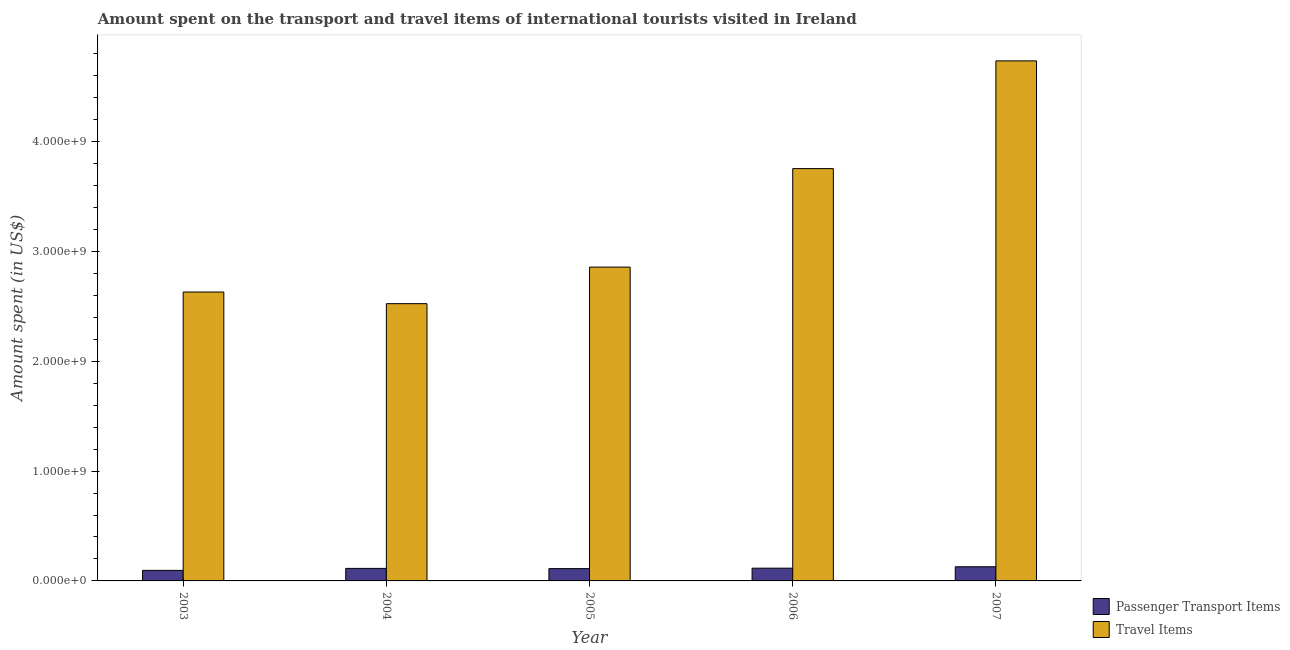How many different coloured bars are there?
Your response must be concise. 2. Are the number of bars per tick equal to the number of legend labels?
Your response must be concise. Yes. Are the number of bars on each tick of the X-axis equal?
Make the answer very short. Yes. How many bars are there on the 1st tick from the left?
Offer a very short reply. 2. How many bars are there on the 2nd tick from the right?
Offer a very short reply. 2. What is the label of the 2nd group of bars from the left?
Make the answer very short. 2004. What is the amount spent on passenger transport items in 2004?
Offer a terse response. 1.14e+08. Across all years, what is the maximum amount spent in travel items?
Give a very brief answer. 4.74e+09. Across all years, what is the minimum amount spent in travel items?
Offer a very short reply. 2.52e+09. In which year was the amount spent on passenger transport items maximum?
Make the answer very short. 2007. In which year was the amount spent in travel items minimum?
Keep it short and to the point. 2004. What is the total amount spent on passenger transport items in the graph?
Provide a short and direct response. 5.67e+08. What is the difference between the amount spent on passenger transport items in 2005 and that in 2006?
Offer a terse response. -4.00e+06. What is the difference between the amount spent in travel items in 2005 and the amount spent on passenger transport items in 2007?
Ensure brevity in your answer.  -1.88e+09. What is the average amount spent in travel items per year?
Keep it short and to the point. 3.30e+09. In the year 2005, what is the difference between the amount spent on passenger transport items and amount spent in travel items?
Offer a terse response. 0. In how many years, is the amount spent in travel items greater than 3400000000 US$?
Provide a short and direct response. 2. What is the ratio of the amount spent in travel items in 2003 to that in 2007?
Make the answer very short. 0.56. Is the difference between the amount spent on passenger transport items in 2004 and 2005 greater than the difference between the amount spent in travel items in 2004 and 2005?
Offer a terse response. No. What is the difference between the highest and the second highest amount spent on passenger transport items?
Your answer should be very brief. 1.30e+07. What is the difference between the highest and the lowest amount spent in travel items?
Provide a succinct answer. 2.21e+09. In how many years, is the amount spent on passenger transport items greater than the average amount spent on passenger transport items taken over all years?
Your answer should be very brief. 3. Is the sum of the amount spent in travel items in 2004 and 2007 greater than the maximum amount spent on passenger transport items across all years?
Offer a terse response. Yes. What does the 1st bar from the left in 2007 represents?
Provide a short and direct response. Passenger Transport Items. What does the 2nd bar from the right in 2004 represents?
Give a very brief answer. Passenger Transport Items. Are the values on the major ticks of Y-axis written in scientific E-notation?
Provide a succinct answer. Yes. Does the graph contain any zero values?
Your answer should be very brief. No. How many legend labels are there?
Your answer should be compact. 2. How are the legend labels stacked?
Offer a very short reply. Vertical. What is the title of the graph?
Make the answer very short. Amount spent on the transport and travel items of international tourists visited in Ireland. What is the label or title of the Y-axis?
Provide a succinct answer. Amount spent (in US$). What is the Amount spent (in US$) of Passenger Transport Items in 2003?
Your answer should be compact. 9.60e+07. What is the Amount spent (in US$) of Travel Items in 2003?
Make the answer very short. 2.63e+09. What is the Amount spent (in US$) in Passenger Transport Items in 2004?
Make the answer very short. 1.14e+08. What is the Amount spent (in US$) in Travel Items in 2004?
Ensure brevity in your answer.  2.52e+09. What is the Amount spent (in US$) of Passenger Transport Items in 2005?
Offer a terse response. 1.12e+08. What is the Amount spent (in US$) of Travel Items in 2005?
Keep it short and to the point. 2.86e+09. What is the Amount spent (in US$) of Passenger Transport Items in 2006?
Make the answer very short. 1.16e+08. What is the Amount spent (in US$) in Travel Items in 2006?
Keep it short and to the point. 3.76e+09. What is the Amount spent (in US$) of Passenger Transport Items in 2007?
Ensure brevity in your answer.  1.29e+08. What is the Amount spent (in US$) in Travel Items in 2007?
Make the answer very short. 4.74e+09. Across all years, what is the maximum Amount spent (in US$) of Passenger Transport Items?
Make the answer very short. 1.29e+08. Across all years, what is the maximum Amount spent (in US$) of Travel Items?
Provide a succinct answer. 4.74e+09. Across all years, what is the minimum Amount spent (in US$) of Passenger Transport Items?
Keep it short and to the point. 9.60e+07. Across all years, what is the minimum Amount spent (in US$) in Travel Items?
Make the answer very short. 2.52e+09. What is the total Amount spent (in US$) of Passenger Transport Items in the graph?
Give a very brief answer. 5.67e+08. What is the total Amount spent (in US$) in Travel Items in the graph?
Provide a short and direct response. 1.65e+1. What is the difference between the Amount spent (in US$) of Passenger Transport Items in 2003 and that in 2004?
Provide a short and direct response. -1.80e+07. What is the difference between the Amount spent (in US$) of Travel Items in 2003 and that in 2004?
Offer a very short reply. 1.06e+08. What is the difference between the Amount spent (in US$) of Passenger Transport Items in 2003 and that in 2005?
Provide a short and direct response. -1.60e+07. What is the difference between the Amount spent (in US$) in Travel Items in 2003 and that in 2005?
Offer a very short reply. -2.27e+08. What is the difference between the Amount spent (in US$) of Passenger Transport Items in 2003 and that in 2006?
Your answer should be very brief. -2.00e+07. What is the difference between the Amount spent (in US$) of Travel Items in 2003 and that in 2006?
Offer a very short reply. -1.12e+09. What is the difference between the Amount spent (in US$) of Passenger Transport Items in 2003 and that in 2007?
Keep it short and to the point. -3.30e+07. What is the difference between the Amount spent (in US$) of Travel Items in 2003 and that in 2007?
Make the answer very short. -2.10e+09. What is the difference between the Amount spent (in US$) in Passenger Transport Items in 2004 and that in 2005?
Your answer should be very brief. 2.00e+06. What is the difference between the Amount spent (in US$) in Travel Items in 2004 and that in 2005?
Make the answer very short. -3.33e+08. What is the difference between the Amount spent (in US$) in Travel Items in 2004 and that in 2006?
Ensure brevity in your answer.  -1.23e+09. What is the difference between the Amount spent (in US$) of Passenger Transport Items in 2004 and that in 2007?
Offer a very short reply. -1.50e+07. What is the difference between the Amount spent (in US$) in Travel Items in 2004 and that in 2007?
Your answer should be compact. -2.21e+09. What is the difference between the Amount spent (in US$) in Travel Items in 2005 and that in 2006?
Your response must be concise. -8.97e+08. What is the difference between the Amount spent (in US$) of Passenger Transport Items in 2005 and that in 2007?
Make the answer very short. -1.70e+07. What is the difference between the Amount spent (in US$) of Travel Items in 2005 and that in 2007?
Offer a very short reply. -1.88e+09. What is the difference between the Amount spent (in US$) in Passenger Transport Items in 2006 and that in 2007?
Provide a short and direct response. -1.30e+07. What is the difference between the Amount spent (in US$) of Travel Items in 2006 and that in 2007?
Keep it short and to the point. -9.81e+08. What is the difference between the Amount spent (in US$) of Passenger Transport Items in 2003 and the Amount spent (in US$) of Travel Items in 2004?
Offer a terse response. -2.43e+09. What is the difference between the Amount spent (in US$) in Passenger Transport Items in 2003 and the Amount spent (in US$) in Travel Items in 2005?
Offer a very short reply. -2.76e+09. What is the difference between the Amount spent (in US$) of Passenger Transport Items in 2003 and the Amount spent (in US$) of Travel Items in 2006?
Offer a terse response. -3.66e+09. What is the difference between the Amount spent (in US$) in Passenger Transport Items in 2003 and the Amount spent (in US$) in Travel Items in 2007?
Keep it short and to the point. -4.64e+09. What is the difference between the Amount spent (in US$) in Passenger Transport Items in 2004 and the Amount spent (in US$) in Travel Items in 2005?
Give a very brief answer. -2.74e+09. What is the difference between the Amount spent (in US$) of Passenger Transport Items in 2004 and the Amount spent (in US$) of Travel Items in 2006?
Your answer should be compact. -3.64e+09. What is the difference between the Amount spent (in US$) in Passenger Transport Items in 2004 and the Amount spent (in US$) in Travel Items in 2007?
Your answer should be very brief. -4.62e+09. What is the difference between the Amount spent (in US$) in Passenger Transport Items in 2005 and the Amount spent (in US$) in Travel Items in 2006?
Give a very brief answer. -3.64e+09. What is the difference between the Amount spent (in US$) of Passenger Transport Items in 2005 and the Amount spent (in US$) of Travel Items in 2007?
Your answer should be very brief. -4.62e+09. What is the difference between the Amount spent (in US$) of Passenger Transport Items in 2006 and the Amount spent (in US$) of Travel Items in 2007?
Your answer should be compact. -4.62e+09. What is the average Amount spent (in US$) in Passenger Transport Items per year?
Give a very brief answer. 1.13e+08. What is the average Amount spent (in US$) of Travel Items per year?
Your answer should be very brief. 3.30e+09. In the year 2003, what is the difference between the Amount spent (in US$) in Passenger Transport Items and Amount spent (in US$) in Travel Items?
Offer a terse response. -2.54e+09. In the year 2004, what is the difference between the Amount spent (in US$) of Passenger Transport Items and Amount spent (in US$) of Travel Items?
Your answer should be very brief. -2.41e+09. In the year 2005, what is the difference between the Amount spent (in US$) of Passenger Transport Items and Amount spent (in US$) of Travel Items?
Offer a terse response. -2.75e+09. In the year 2006, what is the difference between the Amount spent (in US$) of Passenger Transport Items and Amount spent (in US$) of Travel Items?
Offer a very short reply. -3.64e+09. In the year 2007, what is the difference between the Amount spent (in US$) of Passenger Transport Items and Amount spent (in US$) of Travel Items?
Keep it short and to the point. -4.61e+09. What is the ratio of the Amount spent (in US$) of Passenger Transport Items in 2003 to that in 2004?
Make the answer very short. 0.84. What is the ratio of the Amount spent (in US$) in Travel Items in 2003 to that in 2004?
Provide a succinct answer. 1.04. What is the ratio of the Amount spent (in US$) of Travel Items in 2003 to that in 2005?
Ensure brevity in your answer.  0.92. What is the ratio of the Amount spent (in US$) in Passenger Transport Items in 2003 to that in 2006?
Provide a short and direct response. 0.83. What is the ratio of the Amount spent (in US$) of Travel Items in 2003 to that in 2006?
Offer a very short reply. 0.7. What is the ratio of the Amount spent (in US$) in Passenger Transport Items in 2003 to that in 2007?
Your answer should be very brief. 0.74. What is the ratio of the Amount spent (in US$) in Travel Items in 2003 to that in 2007?
Keep it short and to the point. 0.56. What is the ratio of the Amount spent (in US$) of Passenger Transport Items in 2004 to that in 2005?
Ensure brevity in your answer.  1.02. What is the ratio of the Amount spent (in US$) in Travel Items in 2004 to that in 2005?
Offer a terse response. 0.88. What is the ratio of the Amount spent (in US$) of Passenger Transport Items in 2004 to that in 2006?
Give a very brief answer. 0.98. What is the ratio of the Amount spent (in US$) in Travel Items in 2004 to that in 2006?
Your answer should be very brief. 0.67. What is the ratio of the Amount spent (in US$) of Passenger Transport Items in 2004 to that in 2007?
Your answer should be very brief. 0.88. What is the ratio of the Amount spent (in US$) in Travel Items in 2004 to that in 2007?
Keep it short and to the point. 0.53. What is the ratio of the Amount spent (in US$) of Passenger Transport Items in 2005 to that in 2006?
Keep it short and to the point. 0.97. What is the ratio of the Amount spent (in US$) in Travel Items in 2005 to that in 2006?
Provide a succinct answer. 0.76. What is the ratio of the Amount spent (in US$) of Passenger Transport Items in 2005 to that in 2007?
Provide a succinct answer. 0.87. What is the ratio of the Amount spent (in US$) in Travel Items in 2005 to that in 2007?
Keep it short and to the point. 0.6. What is the ratio of the Amount spent (in US$) in Passenger Transport Items in 2006 to that in 2007?
Your answer should be compact. 0.9. What is the ratio of the Amount spent (in US$) of Travel Items in 2006 to that in 2007?
Offer a terse response. 0.79. What is the difference between the highest and the second highest Amount spent (in US$) in Passenger Transport Items?
Your answer should be very brief. 1.30e+07. What is the difference between the highest and the second highest Amount spent (in US$) in Travel Items?
Make the answer very short. 9.81e+08. What is the difference between the highest and the lowest Amount spent (in US$) of Passenger Transport Items?
Offer a very short reply. 3.30e+07. What is the difference between the highest and the lowest Amount spent (in US$) in Travel Items?
Offer a very short reply. 2.21e+09. 